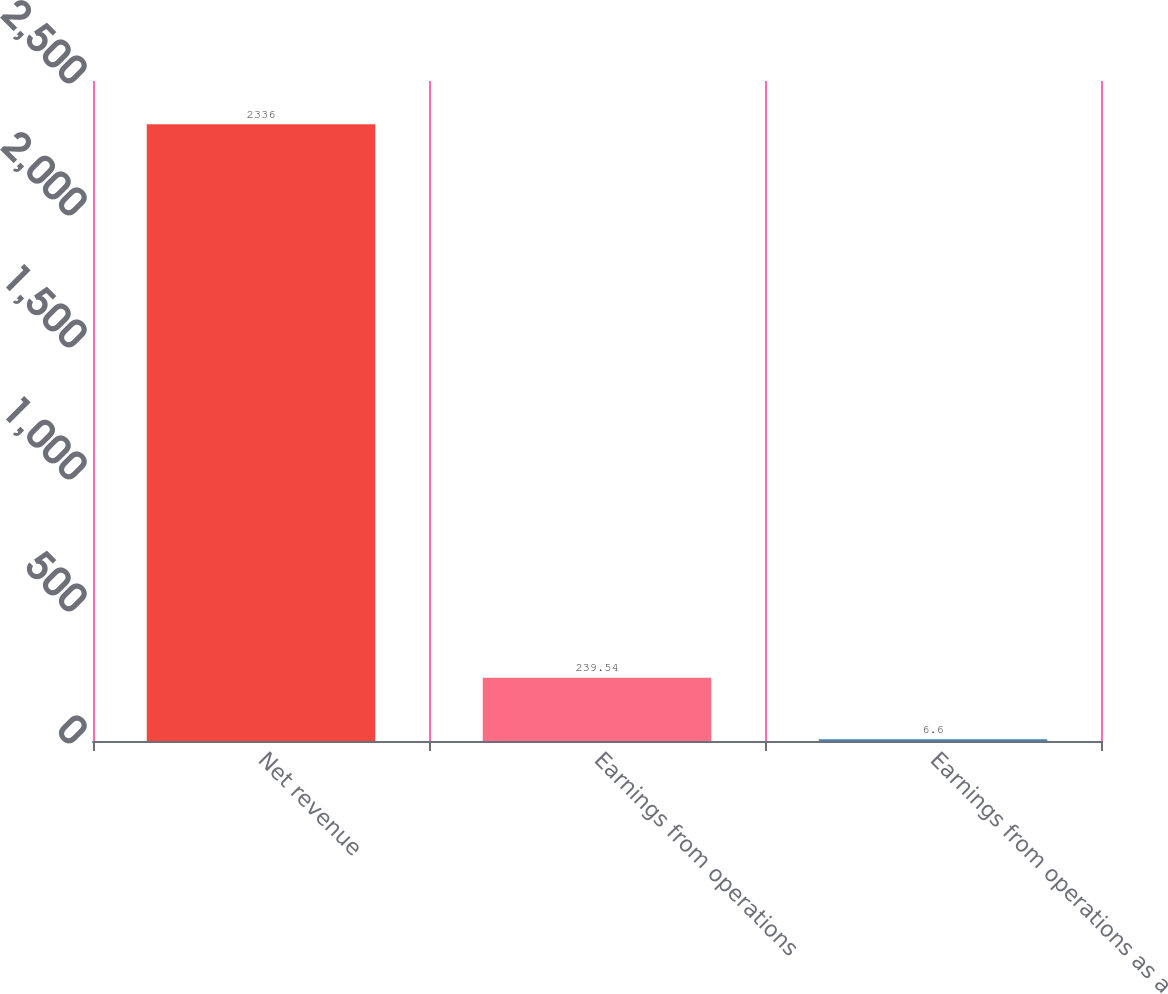<chart> <loc_0><loc_0><loc_500><loc_500><bar_chart><fcel>Net revenue<fcel>Earnings from operations<fcel>Earnings from operations as a<nl><fcel>2336<fcel>239.54<fcel>6.6<nl></chart> 